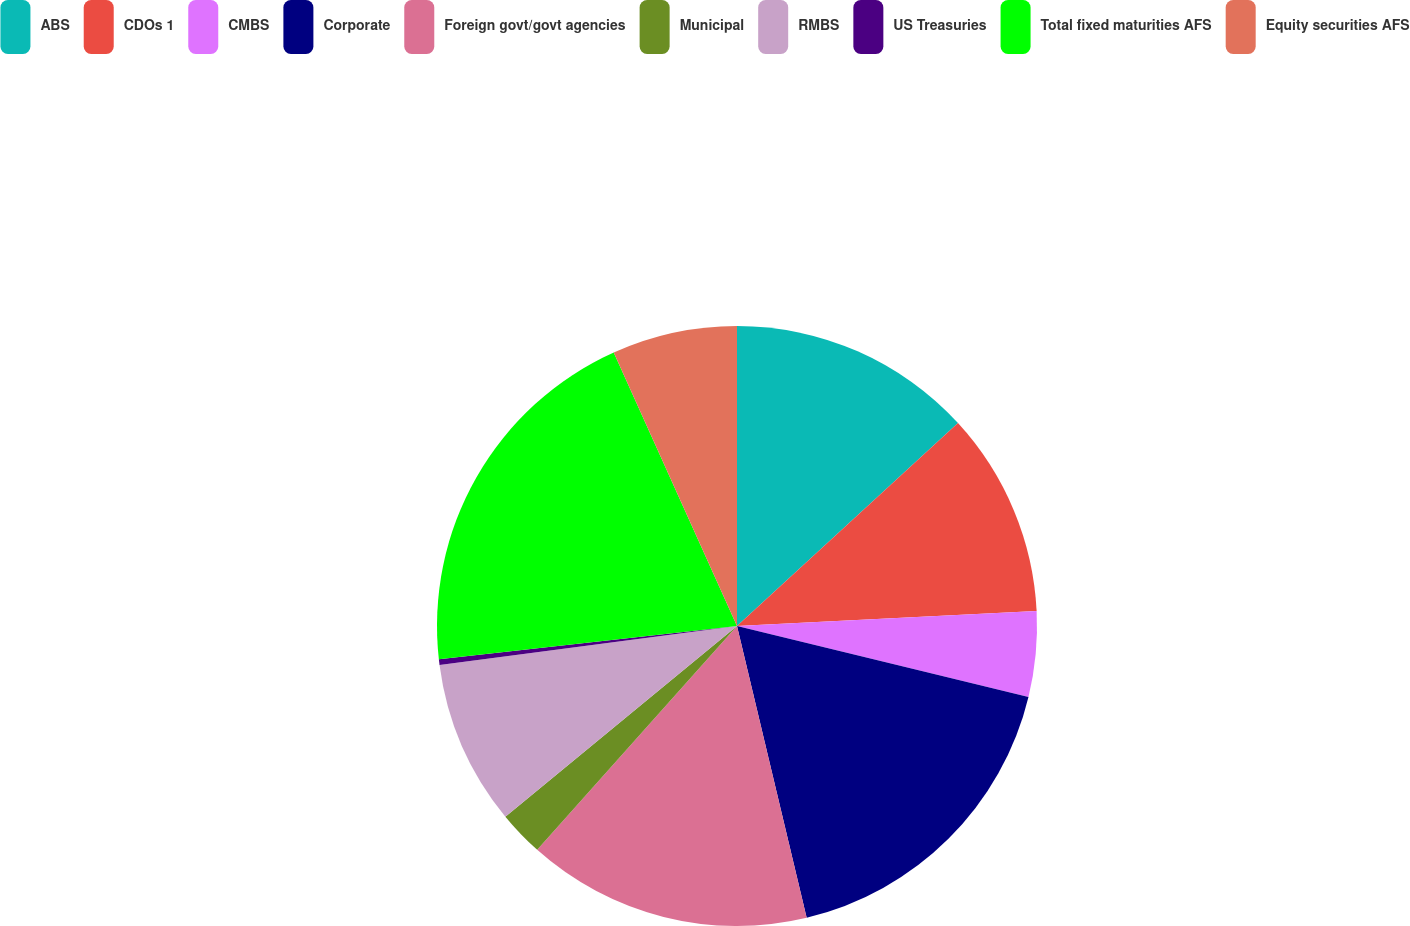Convert chart. <chart><loc_0><loc_0><loc_500><loc_500><pie_chart><fcel>ABS<fcel>CDOs 1<fcel>CMBS<fcel>Corporate<fcel>Foreign govt/govt agencies<fcel>Municipal<fcel>RMBS<fcel>US Treasuries<fcel>Total fixed maturities AFS<fcel>Equity securities AFS<nl><fcel>13.18%<fcel>11.03%<fcel>4.59%<fcel>17.47%<fcel>15.33%<fcel>2.44%<fcel>8.89%<fcel>0.3%<fcel>20.03%<fcel>6.74%<nl></chart> 